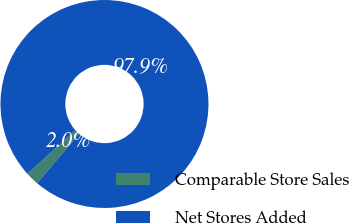Convert chart. <chart><loc_0><loc_0><loc_500><loc_500><pie_chart><fcel>Comparable Store Sales<fcel>Net Stores Added<nl><fcel>2.05%<fcel>97.95%<nl></chart> 